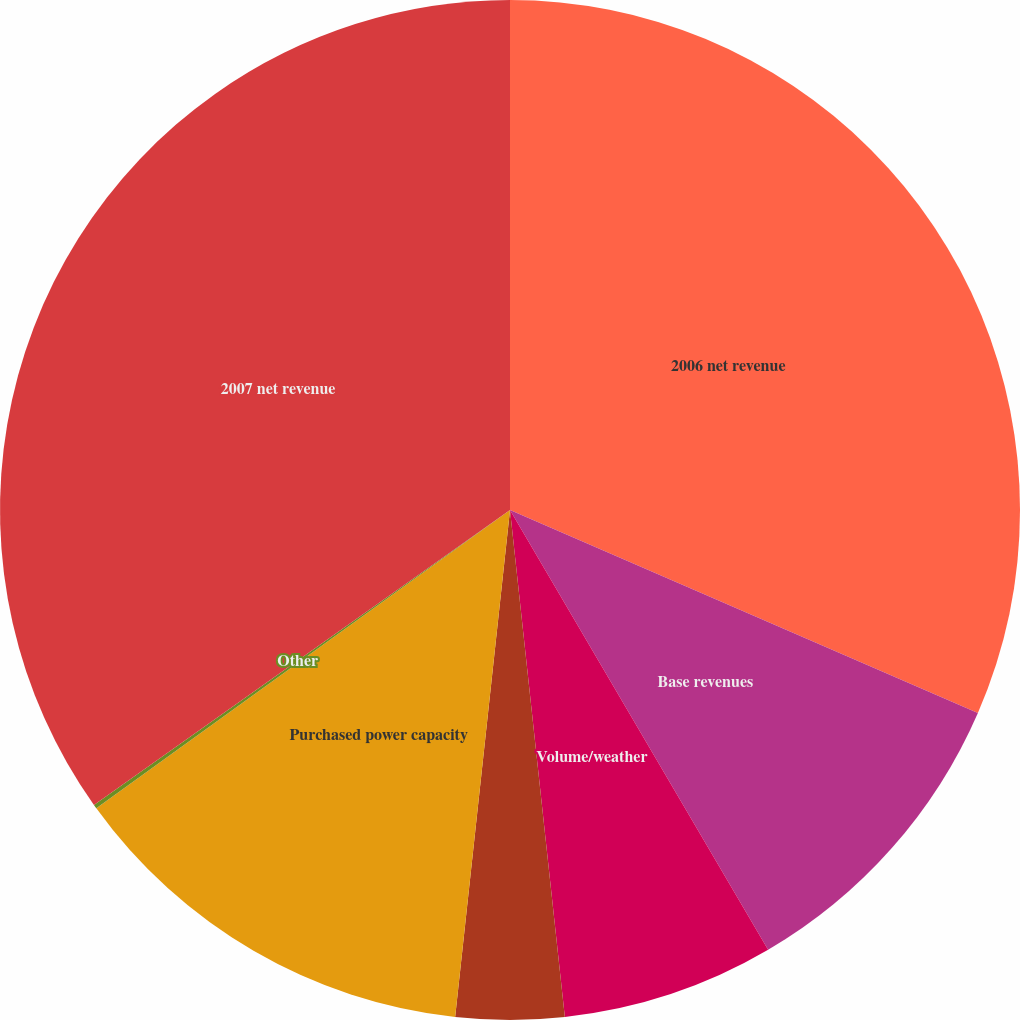<chart> <loc_0><loc_0><loc_500><loc_500><pie_chart><fcel>2006 net revenue<fcel>Base revenues<fcel>Volume/weather<fcel>Transmission revenue<fcel>Purchased power capacity<fcel>Other<fcel>2007 net revenue<nl><fcel>31.51%<fcel>10.04%<fcel>6.73%<fcel>3.43%<fcel>13.34%<fcel>0.13%<fcel>34.81%<nl></chart> 